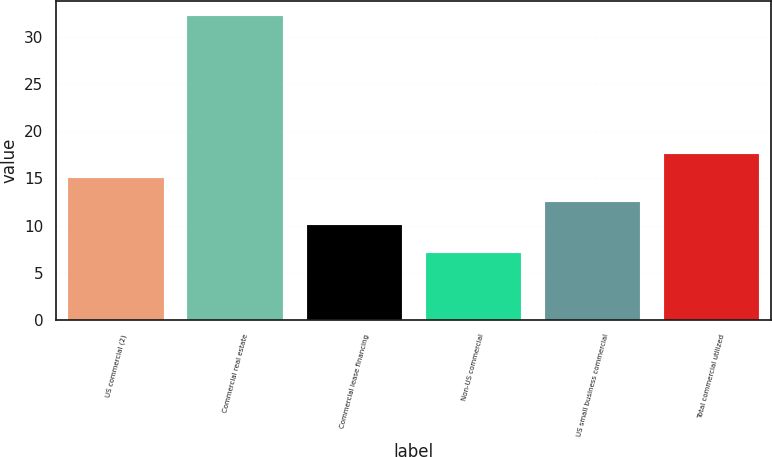Convert chart. <chart><loc_0><loc_0><loc_500><loc_500><bar_chart><fcel>US commercial (2)<fcel>Commercial real estate<fcel>Commercial lease financing<fcel>Non-US commercial<fcel>US small business commercial<fcel>Total commercial utilized<nl><fcel>15.04<fcel>32.13<fcel>10.04<fcel>7.12<fcel>12.54<fcel>17.54<nl></chart> 